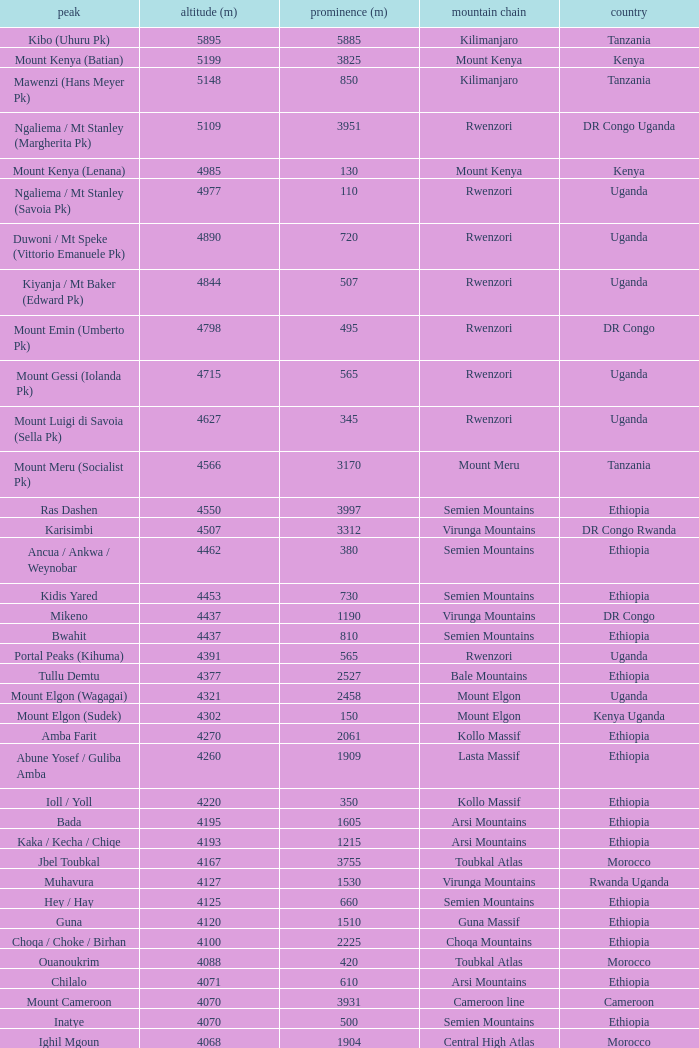Which Country has a Prominence (m) smaller than 1540, and a Height (m) smaller than 3530, and a Range of virunga mountains, and a Mountain of nyiragongo? DR Congo. Parse the full table. {'header': ['peak', 'altitude (m)', 'prominence (m)', 'mountain chain', 'country'], 'rows': [['Kibo (Uhuru Pk)', '5895', '5885', 'Kilimanjaro', 'Tanzania'], ['Mount Kenya (Batian)', '5199', '3825', 'Mount Kenya', 'Kenya'], ['Mawenzi (Hans Meyer Pk)', '5148', '850', 'Kilimanjaro', 'Tanzania'], ['Ngaliema / Mt Stanley (Margherita Pk)', '5109', '3951', 'Rwenzori', 'DR Congo Uganda'], ['Mount Kenya (Lenana)', '4985', '130', 'Mount Kenya', 'Kenya'], ['Ngaliema / Mt Stanley (Savoia Pk)', '4977', '110', 'Rwenzori', 'Uganda'], ['Duwoni / Mt Speke (Vittorio Emanuele Pk)', '4890', '720', 'Rwenzori', 'Uganda'], ['Kiyanja / Mt Baker (Edward Pk)', '4844', '507', 'Rwenzori', 'Uganda'], ['Mount Emin (Umberto Pk)', '4798', '495', 'Rwenzori', 'DR Congo'], ['Mount Gessi (Iolanda Pk)', '4715', '565', 'Rwenzori', 'Uganda'], ['Mount Luigi di Savoia (Sella Pk)', '4627', '345', 'Rwenzori', 'Uganda'], ['Mount Meru (Socialist Pk)', '4566', '3170', 'Mount Meru', 'Tanzania'], ['Ras Dashen', '4550', '3997', 'Semien Mountains', 'Ethiopia'], ['Karisimbi', '4507', '3312', 'Virunga Mountains', 'DR Congo Rwanda'], ['Ancua / Ankwa / Weynobar', '4462', '380', 'Semien Mountains', 'Ethiopia'], ['Kidis Yared', '4453', '730', 'Semien Mountains', 'Ethiopia'], ['Mikeno', '4437', '1190', 'Virunga Mountains', 'DR Congo'], ['Bwahit', '4437', '810', 'Semien Mountains', 'Ethiopia'], ['Portal Peaks (Kihuma)', '4391', '565', 'Rwenzori', 'Uganda'], ['Tullu Demtu', '4377', '2527', 'Bale Mountains', 'Ethiopia'], ['Mount Elgon (Wagagai)', '4321', '2458', 'Mount Elgon', 'Uganda'], ['Mount Elgon (Sudek)', '4302', '150', 'Mount Elgon', 'Kenya Uganda'], ['Amba Farit', '4270', '2061', 'Kollo Massif', 'Ethiopia'], ['Abune Yosef / Guliba Amba', '4260', '1909', 'Lasta Massif', 'Ethiopia'], ['Ioll / Yoll', '4220', '350', 'Kollo Massif', 'Ethiopia'], ['Bada', '4195', '1605', 'Arsi Mountains', 'Ethiopia'], ['Kaka / Kecha / Chiqe', '4193', '1215', 'Arsi Mountains', 'Ethiopia'], ['Jbel Toubkal', '4167', '3755', 'Toubkal Atlas', 'Morocco'], ['Muhavura', '4127', '1530', 'Virunga Mountains', 'Rwanda Uganda'], ['Hey / Hay', '4125', '660', 'Semien Mountains', 'Ethiopia'], ['Guna', '4120', '1510', 'Guna Massif', 'Ethiopia'], ['Choqa / Choke / Birhan', '4100', '2225', 'Choqa Mountains', 'Ethiopia'], ['Ouanoukrim', '4088', '420', 'Toubkal Atlas', 'Morocco'], ['Chilalo', '4071', '610', 'Arsi Mountains', 'Ethiopia'], ['Mount Cameroon', '4070', '3931', 'Cameroon line', 'Cameroon'], ['Inatye', '4070', '500', 'Semien Mountains', 'Ethiopia'], ['Ighil Mgoun', '4068', '1904', 'Central High Atlas', 'Morocco'], ['Weshema / Wasema?', '4030', '420', 'Bale Mountains', 'Ethiopia'], ['Oldoinyo Lesatima', '4001', '2081', 'Aberdare Range', 'Kenya'], ["Jebel n'Tarourt / Tifnout / Iferouane", '3996', '910', 'Toubkal Atlas', 'Morocco'], ['Muggia', '3950', '500', 'Lasta Massif', 'Ethiopia'], ['Dubbai', '3941', '1540', 'Tigray Mountains', 'Ethiopia'], ['Taska n’Zat', '3912', '460', 'Toubkal Atlas', 'Morocco'], ['Aksouâl', '3903', '450', 'Toubkal Atlas', 'Morocco'], ['Mount Kinangop', '3902', '530', 'Aberdare Range', 'Kenya'], ['Cimbia', '3900', '590', 'Kollo Massif', 'Ethiopia'], ['Anrhemer / Ingehmar', '3892', '380', 'Toubkal Atlas', 'Morocco'], ['Ieciuol ?', '3840', '560', 'Kollo Massif', 'Ethiopia'], ['Kawa / Caua / Lajo', '3830', '475', 'Bale Mountains', 'Ethiopia'], ['Pt 3820', '3820', '450', 'Kollo Massif', 'Ethiopia'], ['Jbel Tignousti', '3819', '930', 'Central High Atlas', 'Morocco'], ['Filfo / Encuolo', '3805', '770', 'Arsi Mountains', 'Ethiopia'], ['Kosso Amba', '3805', '530', 'Lasta Massif', 'Ethiopia'], ['Jbel Ghat', '3781', '470', 'Central High Atlas', 'Morocco'], ['Baylamtu / Gavsigivla', '3777', '1120', 'Lasta Massif', 'Ethiopia'], ['Ouaougoulzat', '3763', '860', 'Central High Atlas', 'Morocco'], ['Somkaru', '3760', '530', 'Bale Mountains', 'Ethiopia'], ['Abieri', '3750', '780', 'Semien Mountains', 'Ethiopia'], ['Arin Ayachi', '3747', '1400', 'East High Atlas', 'Morocco'], ['Teide', '3718', '3718', 'Tenerife', 'Canary Islands'], ['Visoke / Bisoke', '3711', '585', 'Virunga Mountains', 'DR Congo Rwanda'], ['Sarenga', '3700', '1160', 'Tigray Mountains', 'Ethiopia'], ['Woti / Uoti', '3700', '1050', 'Eastern Escarpment', 'Ethiopia'], ['Pt 3700 (Kulsa?)', '3700', '490', 'Arsi Mountains', 'Ethiopia'], ['Loolmalassin', '3682', '2040', 'Crater Highlands', 'Tanzania'], ['Biala ?', '3680', '870', 'Lasta Massif', 'Ethiopia'], ['Azurki / Azourki', '3677', '790', 'Central High Atlas', 'Morocco'], ['Pt 3645', '3645', '910', 'Lasta Massif', 'Ethiopia'], ['Sabyinyo', '3634', '1010', 'Virunga Mountains', 'Rwanda DR Congo Uganda'], ['Mount Gurage / Guraghe', '3620', '1400', 'Gurage Mountains', 'Ethiopia'], ['Angour', '3616', '444', 'Toubkal Atlas', 'Morocco'], ['Jbel Igdat', '3615', '1609', 'West High Atlas', 'Morocco'], ["Jbel n'Anghomar", '3609', '1420', 'Central High Atlas', 'Morocco'], ['Yegura / Amba Moka', '3605', '420', 'Lasta Massif', 'Ethiopia'], ['Pt 3600 (Kitir?)', '3600', '870', 'Eastern Escarpment', 'Ethiopia'], ['Pt 3600', '3600', '610', 'Lasta Massif', 'Ethiopia'], ['Bar Meda high point', '3580', '520', 'Eastern Escarpment', 'Ethiopia'], ['Jbel Erdouz', '3579', '690', 'West High Atlas', 'Morocco'], ['Mount Gugu', '3570', '940', 'Mount Gugu', 'Ethiopia'], ['Gesh Megal (?)', '3570', '520', 'Gurage Mountains', 'Ethiopia'], ['Gughe', '3568', '2013', 'Balta Mountains', 'Ethiopia'], ['Megezez', '3565', '690', 'Eastern Escarpment', 'Ethiopia'], ['Pt 3555', '3555', '475', 'Lasta Massif', 'Ethiopia'], ['Jbel Tinergwet', '3551', '880', 'West High Atlas', 'Morocco'], ['Amba Alagi', '3550', '820', 'Tigray Mountains', 'Ethiopia'], ['Nakugen', '3530', '1510', 'Cherangany Hills', 'Kenya'], ['Gara Guda /Kara Gada', '3530', '900', 'Salale Mountains', 'Ethiopia'], ['Amonewas', '3530', '870', 'Choqa Mountains', 'Ethiopia'], ['Amedamit', '3530', '760', 'Choqa Mountains', 'Ethiopia'], ['Igoudamene', '3519', '550', 'Central High Atlas', 'Morocco'], ['Abuye Meda', '3505', '230', 'Eastern Escarpment', 'Ethiopia'], ['Thabana Ntlenyana', '3482', '2390', 'Drakensberg', 'Lesotho'], ['Mont Mohi', '3480', '1592', 'Mitumba Mountains', 'DR Congo'], ['Gahinga', '3474', '425', 'Virunga Mountains', 'Uganda Rwanda'], ['Nyiragongo', '3470', '1440', 'Virunga Mountains', 'DR Congo']]} 